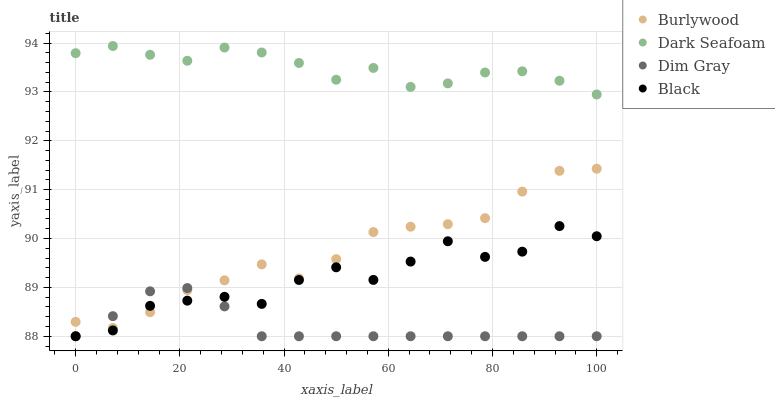Does Dim Gray have the minimum area under the curve?
Answer yes or no. Yes. Does Dark Seafoam have the maximum area under the curve?
Answer yes or no. Yes. Does Dark Seafoam have the minimum area under the curve?
Answer yes or no. No. Does Dim Gray have the maximum area under the curve?
Answer yes or no. No. Is Dim Gray the smoothest?
Answer yes or no. Yes. Is Black the roughest?
Answer yes or no. Yes. Is Dark Seafoam the smoothest?
Answer yes or no. No. Is Dark Seafoam the roughest?
Answer yes or no. No. Does Dim Gray have the lowest value?
Answer yes or no. Yes. Does Dark Seafoam have the lowest value?
Answer yes or no. No. Does Dark Seafoam have the highest value?
Answer yes or no. Yes. Does Dim Gray have the highest value?
Answer yes or no. No. Is Burlywood less than Dark Seafoam?
Answer yes or no. Yes. Is Dark Seafoam greater than Burlywood?
Answer yes or no. Yes. Does Black intersect Dim Gray?
Answer yes or no. Yes. Is Black less than Dim Gray?
Answer yes or no. No. Is Black greater than Dim Gray?
Answer yes or no. No. Does Burlywood intersect Dark Seafoam?
Answer yes or no. No. 